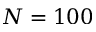Convert formula to latex. <formula><loc_0><loc_0><loc_500><loc_500>N = 1 0 0</formula> 